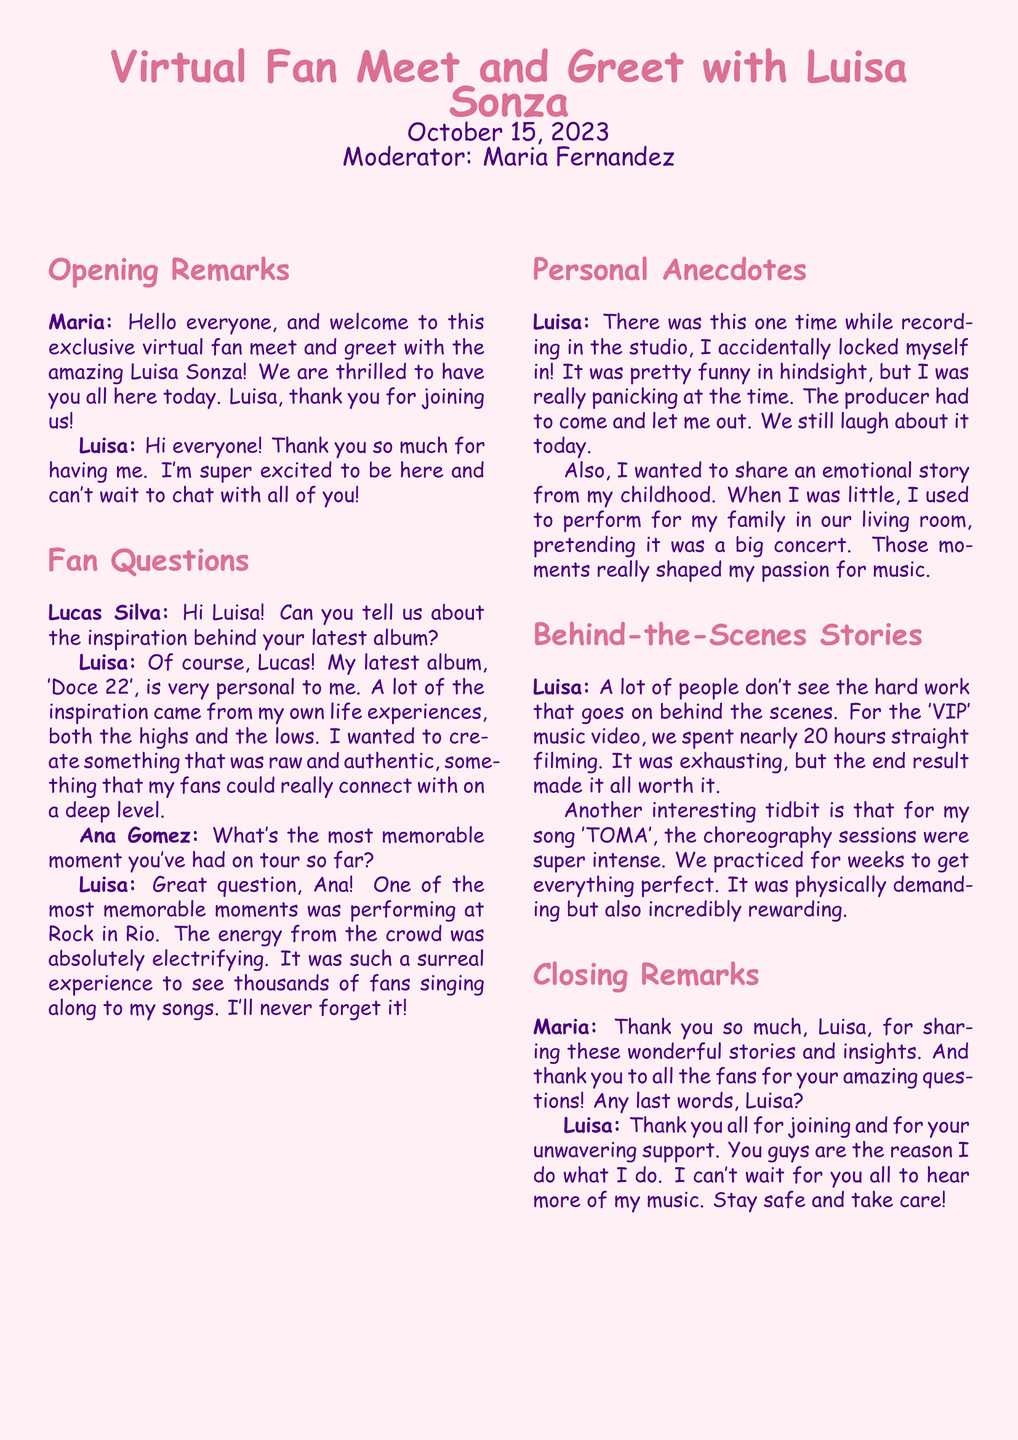What is the title of Luisa Sonza's latest album? The title of Luisa Sonza's latest album is mentioned in the document as 'Doce 22'.
Answer: 'Doce 22' Who moderated the virtual meet and greet? The document states that Maria Fernandez was the moderator for the event.
Answer: Maria Fernandez What is the most memorable tour moment mentioned by Luisa? Luisa mentions performing at Rock in Rio as her most memorable moment on tour.
Answer: Rock in Rio How long did they film the 'VIP' music video? The document indicates that the filming of the 'VIP' music video took nearly 20 hours straight.
Answer: 20 hours What childhood activity inspired Luisa's passion for music? Luisa shared that she used to perform for her family in their living room.
Answer: Performing for family What did Luisa accidentally do while recording in the studio? According to the document, Luisa accidentally locked herself in the studio while recording.
Answer: Locked herself in Which song had intense choreography sessions? The document mentions that the song 'TOMA' had super intense choreography sessions.
Answer: 'TOMA' What date did the virtual fan meet and greet take place? The document specifies that the virtual fan meet and greet occurred on October 15, 2023.
Answer: October 15, 2023 